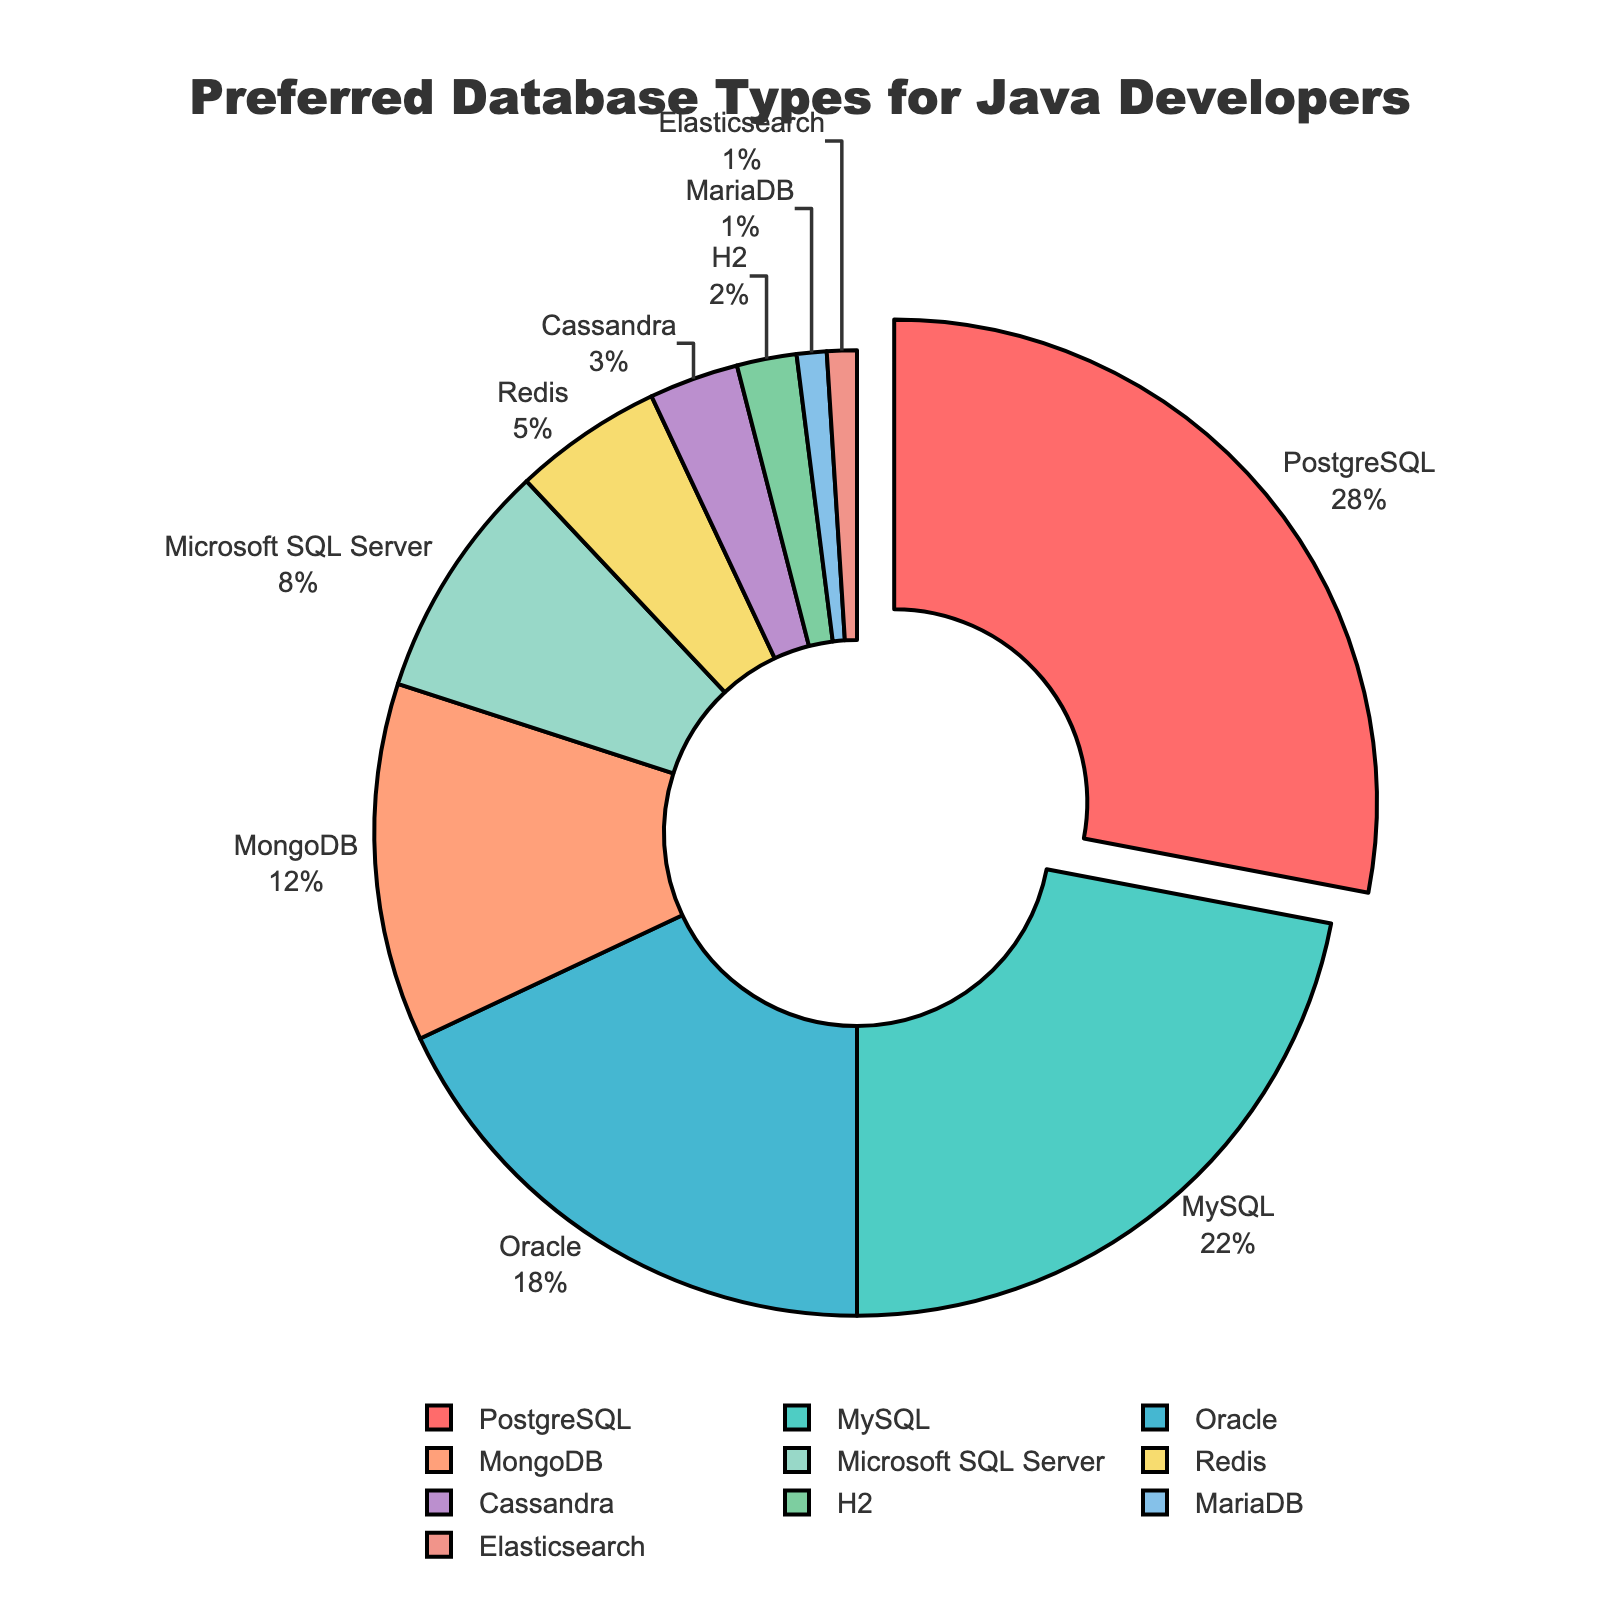Which database type is preferred the most by Java developers? The database type with the highest percentage in the pie chart is considered the most preferred. From the chart, PostgreSQL has the largest segment and is highlighted.
Answer: PostgreSQL Which database type is preferred the least by Java developers? The database type with the lowest percentage in the pie chart is the least preferred. From the chart, both MariaDB and Elasticsearch have the smallest segments.
Answer: MariaDB and Elasticsearch How much more popular is PostgreSQL compared to MySQL? PostgreSQL has 28%, and MySQL has 22%. The difference is calculated as 28% - 22% = 6%.
Answer: 6% What is the total percentage of preferences for relational databases (PostgreSQL, MySQL, Oracle, Microsoft SQL Server, and MariaDB)? Sum the percentages of all specified relational databases: 28% (PostgreSQL) + 22% (MySQL) + 18% (Oracle) + 8% (Microsoft SQL Server) + 1% (MariaDB) = 77%.
Answer: 77% What is the combined percentage for non-relational databases (MongoDB, Redis, Cassandra, Elasticsearch)? Sum the percentages of the specified non-relational databases: 12% (MongoDB) + 5% (Redis) + 3% (Cassandra) + 1% (Elasticsearch) = 21%.
Answer: 21% Which database type is preferred more, MongoDB or Oracle, and by what percentage? Compare the percentages of MongoDB and Oracle. MongoDB has 12%, and Oracle has 18%. The difference is calculated as 18% - 12% = 6%.
Answer: Oracle by 6% If PostgreSQL and MySQL were combined into one category, what would be their total percentage? Sum the percentages of PostgreSQL and MySQL: 28% (PostgreSQL) + 22% (MySQL) = 50%.
Answer: 50% Which segment appears in green? The pie chart's legend or color mapping can identify segments' colors. According to the color scheme, MySQL is in green.
Answer: MySQL Are relational or non-relational databases generally more preferred by Java developers? Compare the total percentages calculated for relational (77%) and non-relational databases (21%). Relational databases have a higher total percentage.
Answer: Relational databases Which database types have a preference percentage greater than 10%? Identify which segments in the pie chart have percentages greater than 10%. These are PostgreSQL (28%), MySQL (22%), Oracle (18%), and MongoDB (12%).
Answer: PostgreSQL, MySQL, Oracle, and MongoDB 